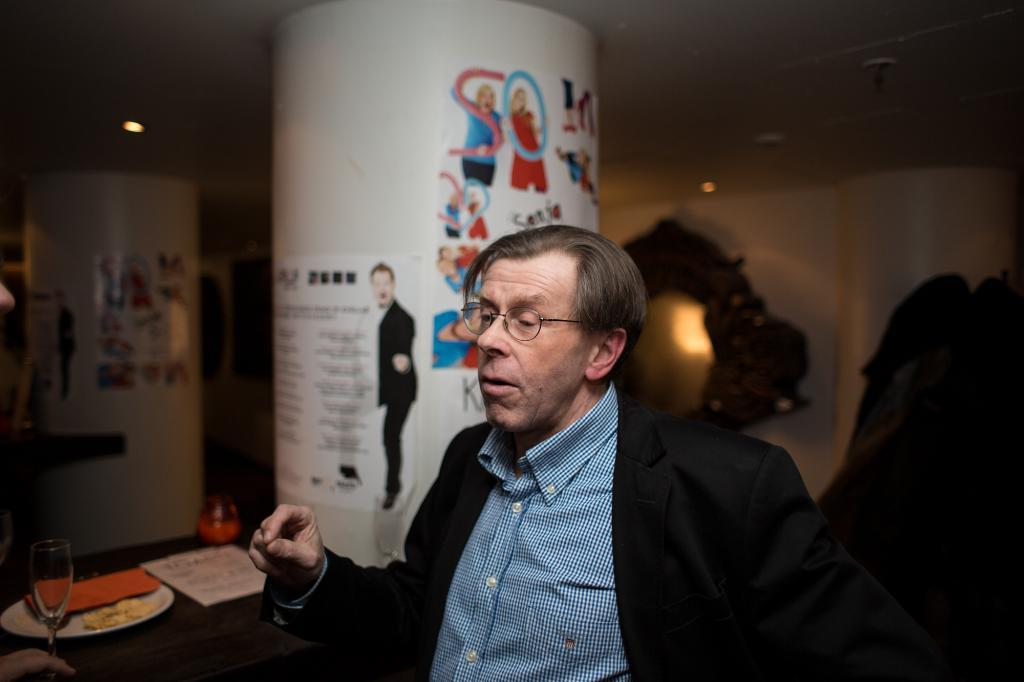Who is present in the image? There is a man in the image. What is the man doing in the image? The man is sitting on a chair. Where is the chair located in relation to the table? The chair is in front of a table. What can be found on the table in the image? There are objects on the table. What type of flowers can be seen on the boat in the image? There is no boat or flowers present in the image. 